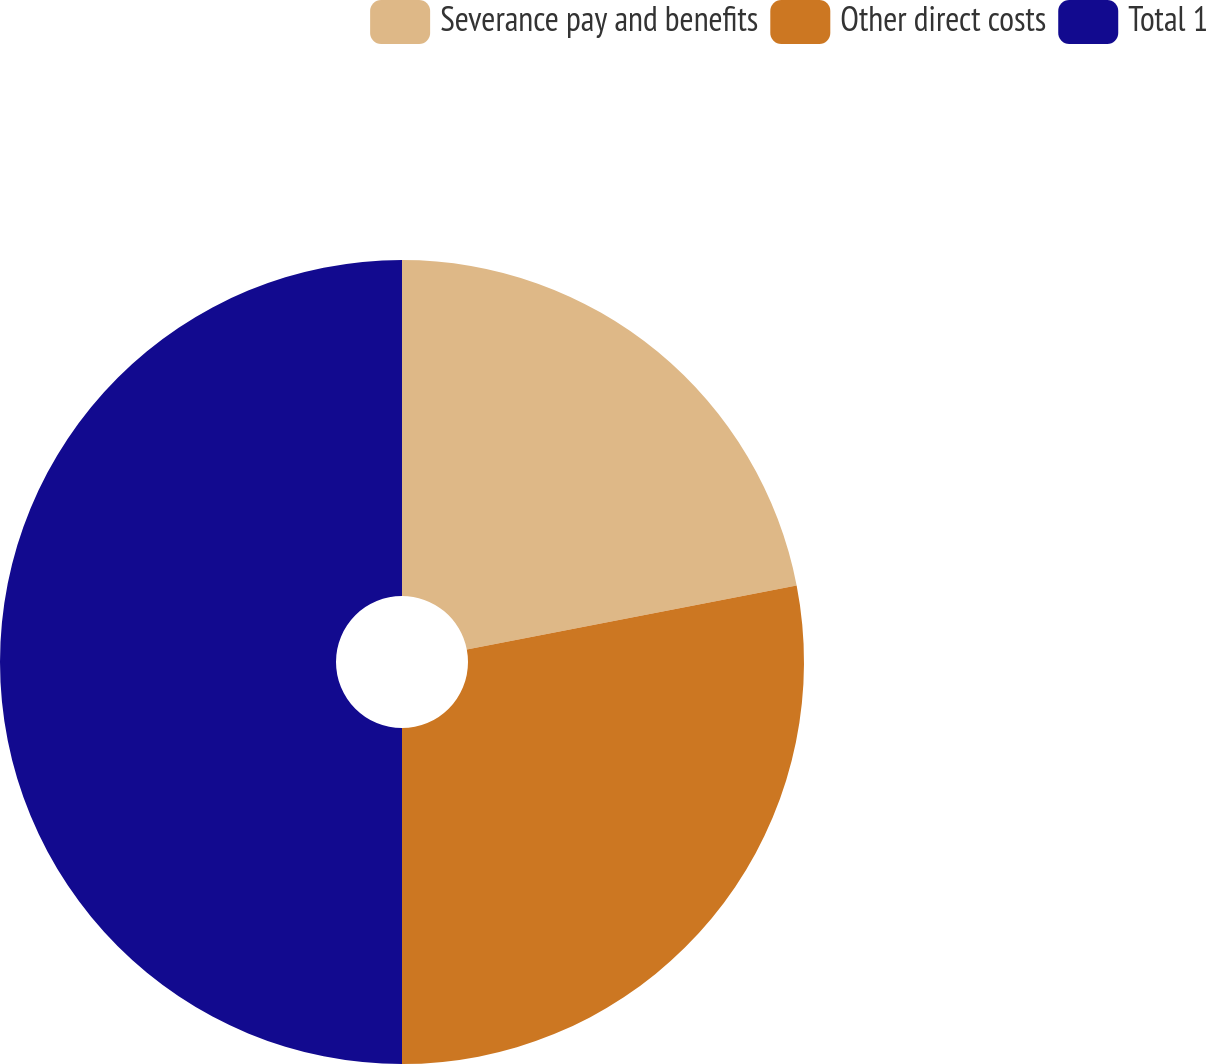<chart> <loc_0><loc_0><loc_500><loc_500><pie_chart><fcel>Severance pay and benefits<fcel>Other direct costs<fcel>Total 1<nl><fcel>21.95%<fcel>28.05%<fcel>50.0%<nl></chart> 